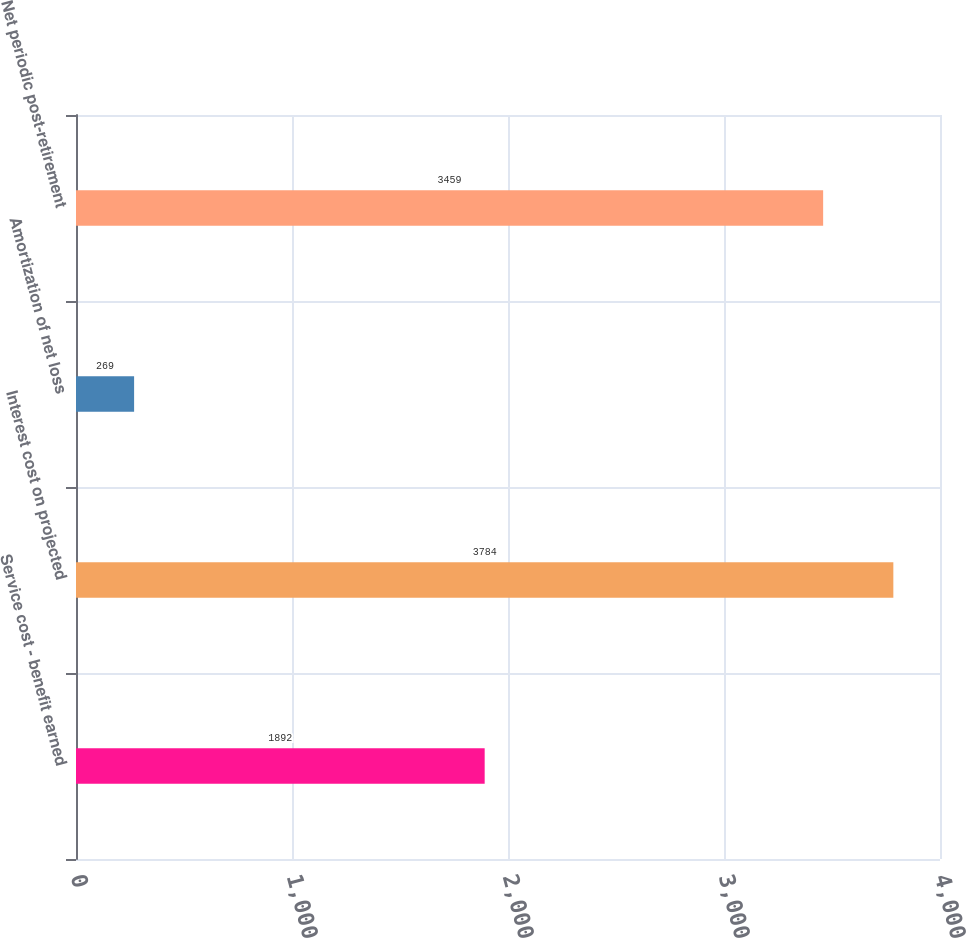Convert chart to OTSL. <chart><loc_0><loc_0><loc_500><loc_500><bar_chart><fcel>Service cost - benefit earned<fcel>Interest cost on projected<fcel>Amortization of net loss<fcel>Net periodic post-retirement<nl><fcel>1892<fcel>3784<fcel>269<fcel>3459<nl></chart> 